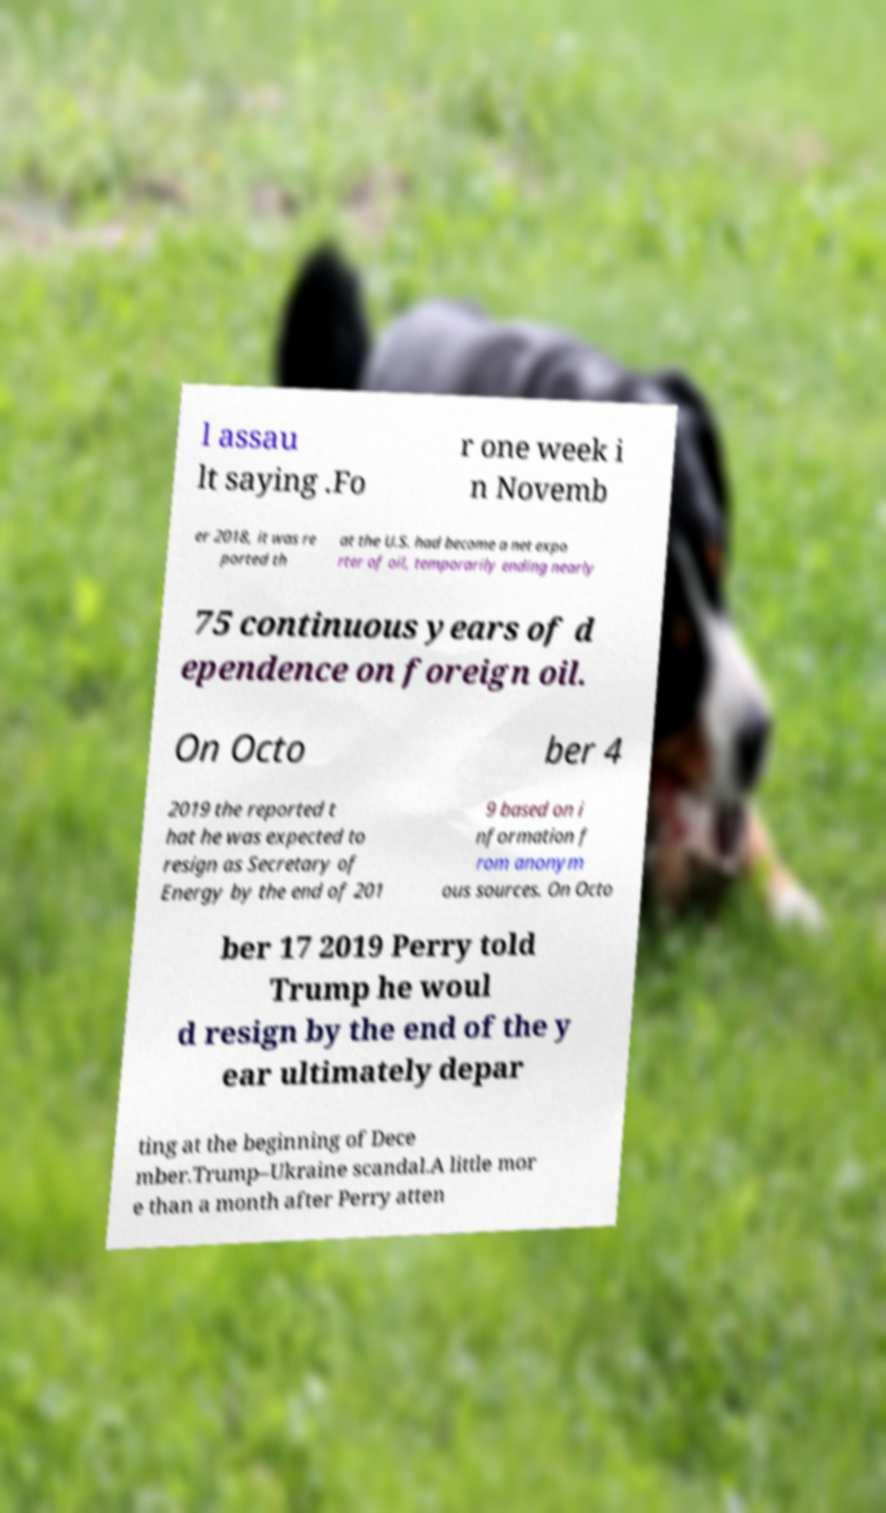For documentation purposes, I need the text within this image transcribed. Could you provide that? l assau lt saying .Fo r one week i n Novemb er 2018, it was re ported th at the U.S. had become a net expo rter of oil, temporarily ending nearly 75 continuous years of d ependence on foreign oil. On Octo ber 4 2019 the reported t hat he was expected to resign as Secretary of Energy by the end of 201 9 based on i nformation f rom anonym ous sources. On Octo ber 17 2019 Perry told Trump he woul d resign by the end of the y ear ultimately depar ting at the beginning of Dece mber.Trump–Ukraine scandal.A little mor e than a month after Perry atten 